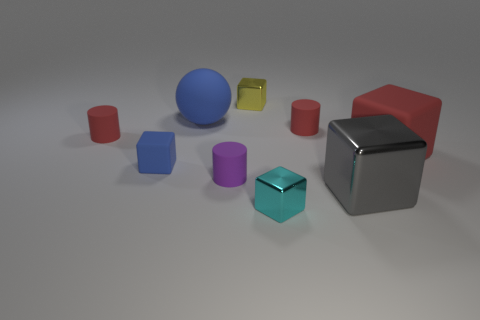Subtract all red matte cylinders. How many cylinders are left? 1 Add 1 purple objects. How many objects exist? 10 Subtract all gray blocks. How many blocks are left? 4 Subtract 0 blue cylinders. How many objects are left? 9 Subtract all balls. How many objects are left? 8 Subtract 2 cylinders. How many cylinders are left? 1 Subtract all red blocks. Subtract all blue balls. How many blocks are left? 4 Subtract all gray cylinders. How many gray cubes are left? 1 Subtract all big purple metal cylinders. Subtract all small rubber objects. How many objects are left? 5 Add 6 tiny purple things. How many tiny purple things are left? 7 